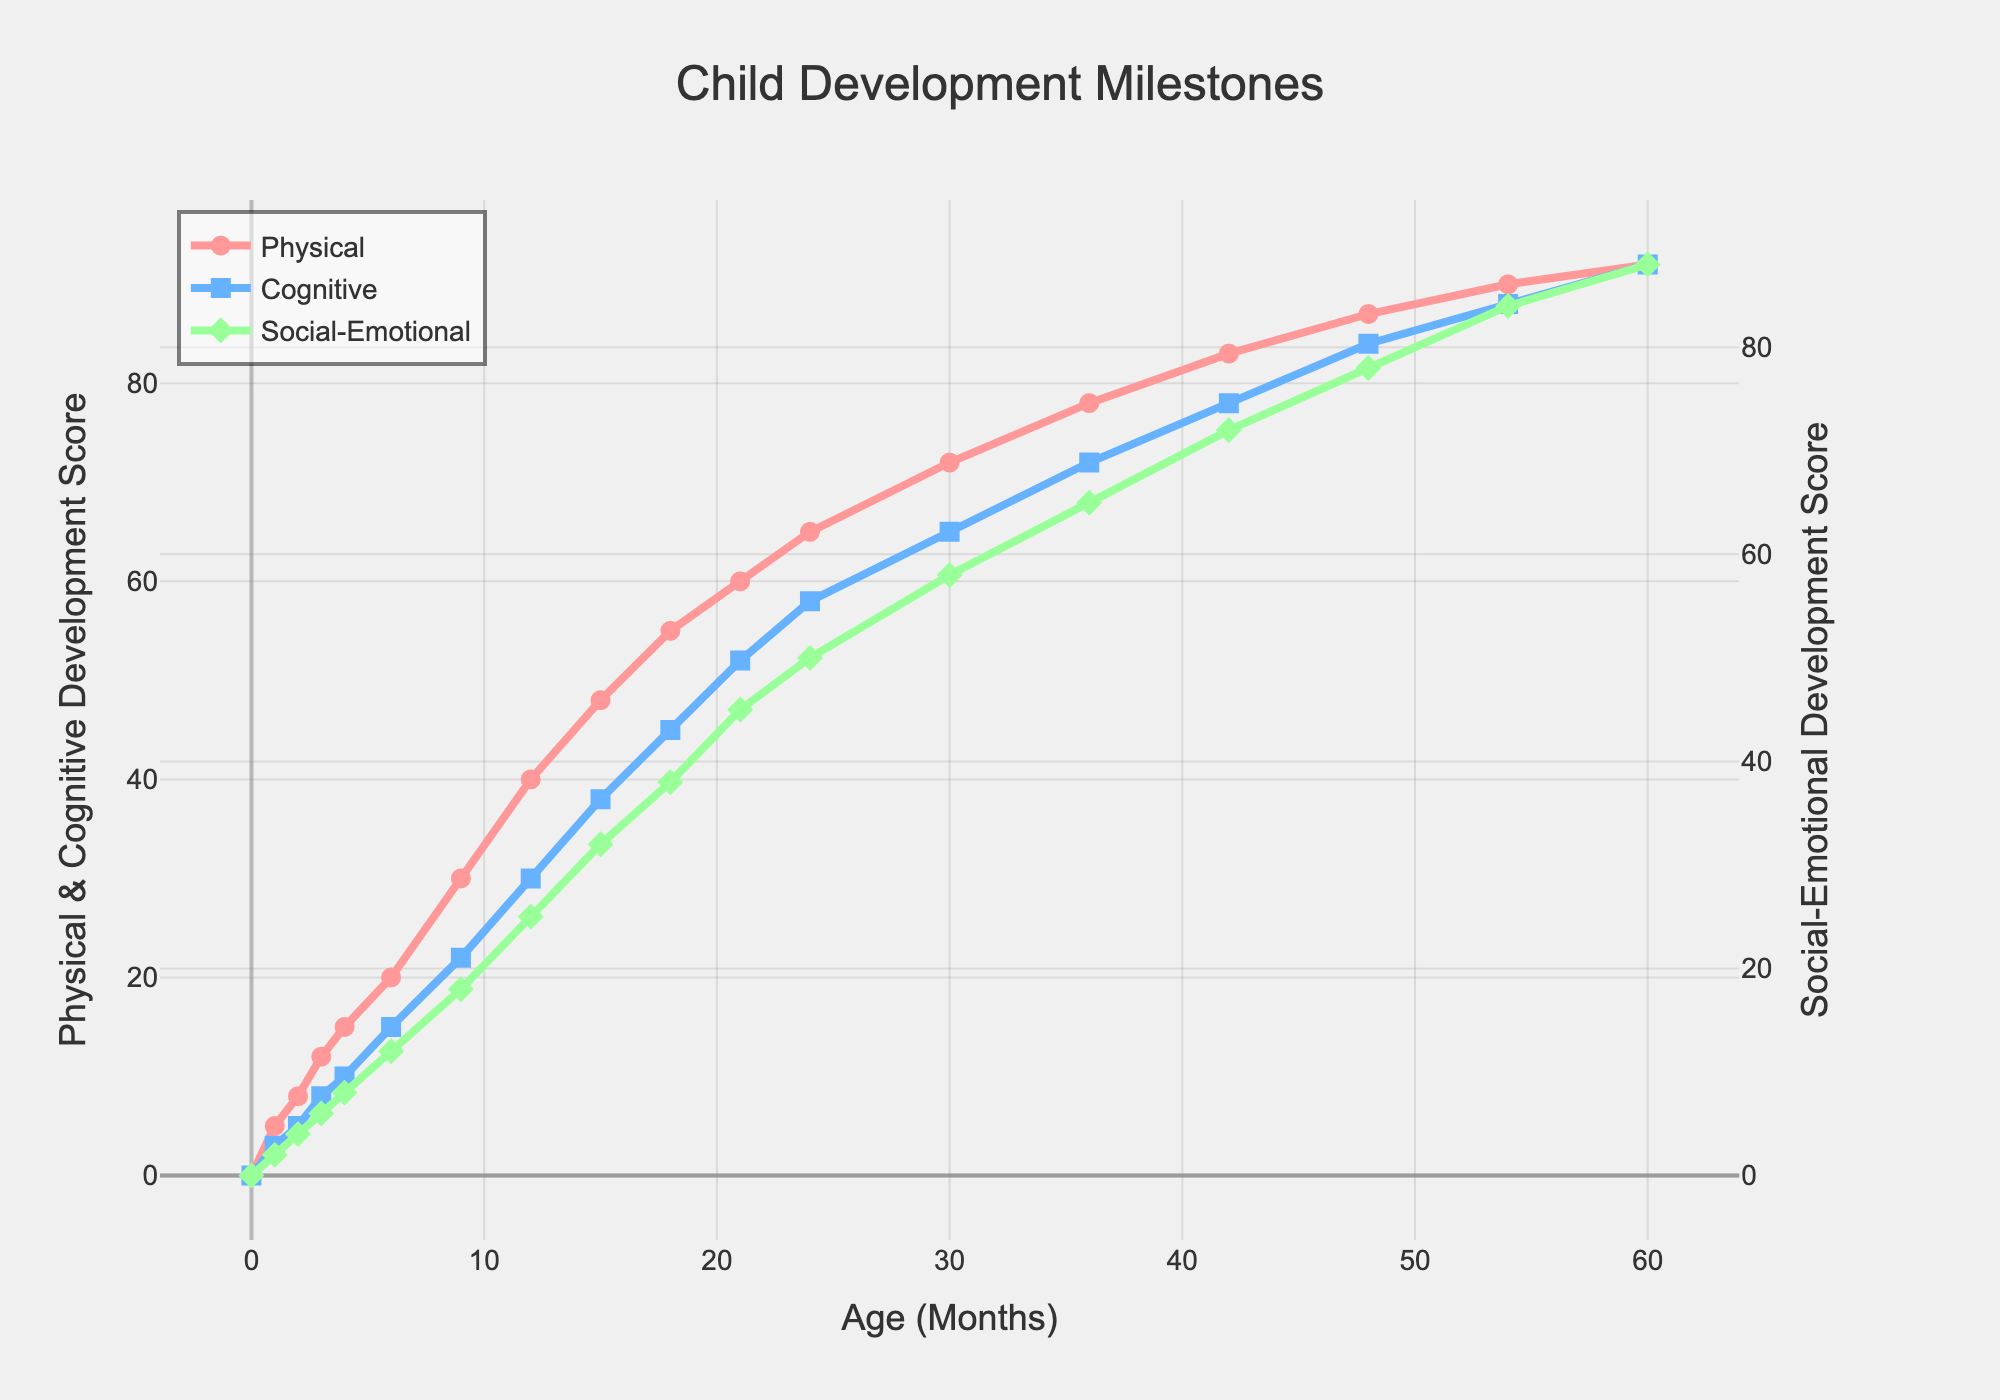Which developmental milestone (Physical, Cognitive, or Social-Emotional) shows the highest score at the 12-month mark? By looking at the 12-month mark on the x-axis and comparing the heights of all three lines, the Physical score is the highest.
Answer: Physical At what age (in months) does the Social-Emotional score first exceed 50? Look across the Social-Emotional line and find the first occurrence where the value exceeds 50. It occurs between 21 and 24 months, observed at Age 24 months.
Answer: 24 months Compare the Cognitive and Social-Emotional scores at 6 months. Which one is higher and by how much? Check the values for both Cognitive (15) and Social-Emotional (12) at 6 months and find the difference. Cognitive is higher by 3 points.
Answer: Cognitive by 3 points What is the average Physical score between Ages 9 and 18 months? Values at 9, 12, 15, and 18 months are 30, 40, 48, and 55 respectively. Calculate the average: (30 + 40 + 48 + 55) / 4 = 43.25.
Answer: 43.25 Between which age intervals is the steepest growth observed in the Cognitive development curve? Observe the slope of the Cognitive line between consecutive points. The steepest change occurs between 0 and 6 months (from 0 to 15).
Answer: 0 to 6 months How does the Social-Emotional curve differ visually from the Physical and Cognitive curves in terms of axes? The Social-Emotional curve is plotted against the secondary y-axis on the right, whereas the Physical and Cognitive are against the primary y-axis on the left.
Answer: Secondary y-axis What is the difference in Social-Emotional scores between 48 and 60 months? Subtract the value at 48 months (78) from the value at 60 months (88). The difference is 10 points.
Answer: 10 points What is the cumulative score of Cognitive development up to 12 months? Add the Cognitive values from 0 to 12 months: 0 + 3 + 5 + 8 + 10 + 15 + 22 + 30 = 93.
Answer: 93 Around what age does the Physical score appear to level off? The Physical line starts to plateau around 54-60 months, showing minimal increase.
Answer: 54-60 months 